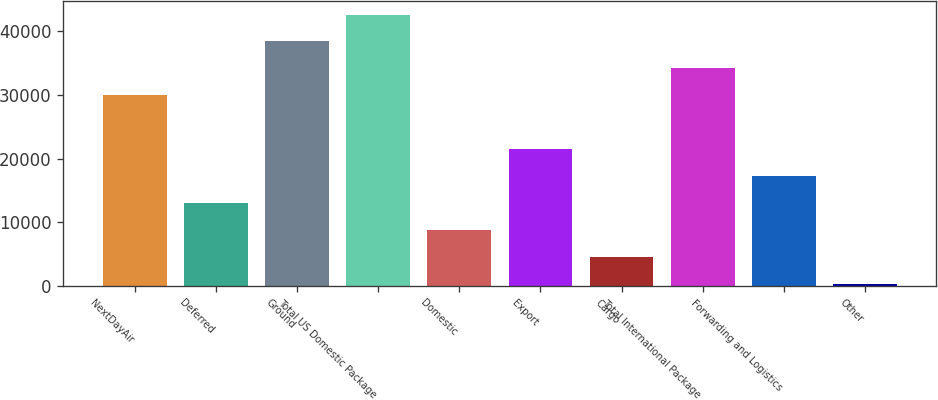Convert chart to OTSL. <chart><loc_0><loc_0><loc_500><loc_500><bar_chart><fcel>NextDayAir<fcel>Deferred<fcel>Ground<fcel>Total US Domestic Package<fcel>Domestic<fcel>Export<fcel>Cargo<fcel>Total International Package<fcel>Forwarding and Logistics<fcel>Other<nl><fcel>29908.1<fcel>13010.9<fcel>38356.7<fcel>42581<fcel>8786.6<fcel>21459.5<fcel>4562.3<fcel>34132.4<fcel>17235.2<fcel>338<nl></chart> 